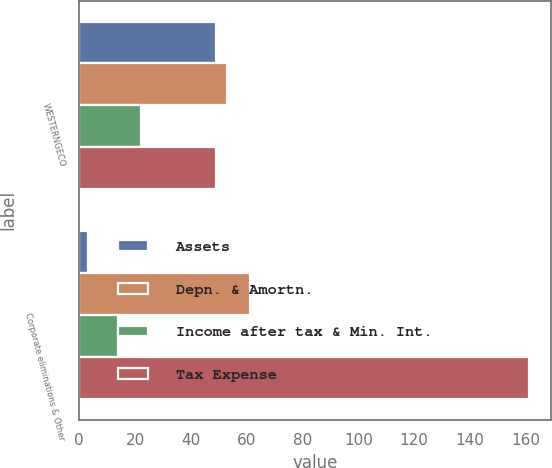Convert chart. <chart><loc_0><loc_0><loc_500><loc_500><stacked_bar_chart><ecel><fcel>WESTERNGECO<fcel>Corporate eliminations & Other<nl><fcel>Assets<fcel>49<fcel>3<nl><fcel>Depn. & Amortn.<fcel>53<fcel>61<nl><fcel>Income after tax & Min. Int.<fcel>22<fcel>14<nl><fcel>Tax Expense<fcel>49<fcel>161<nl></chart> 